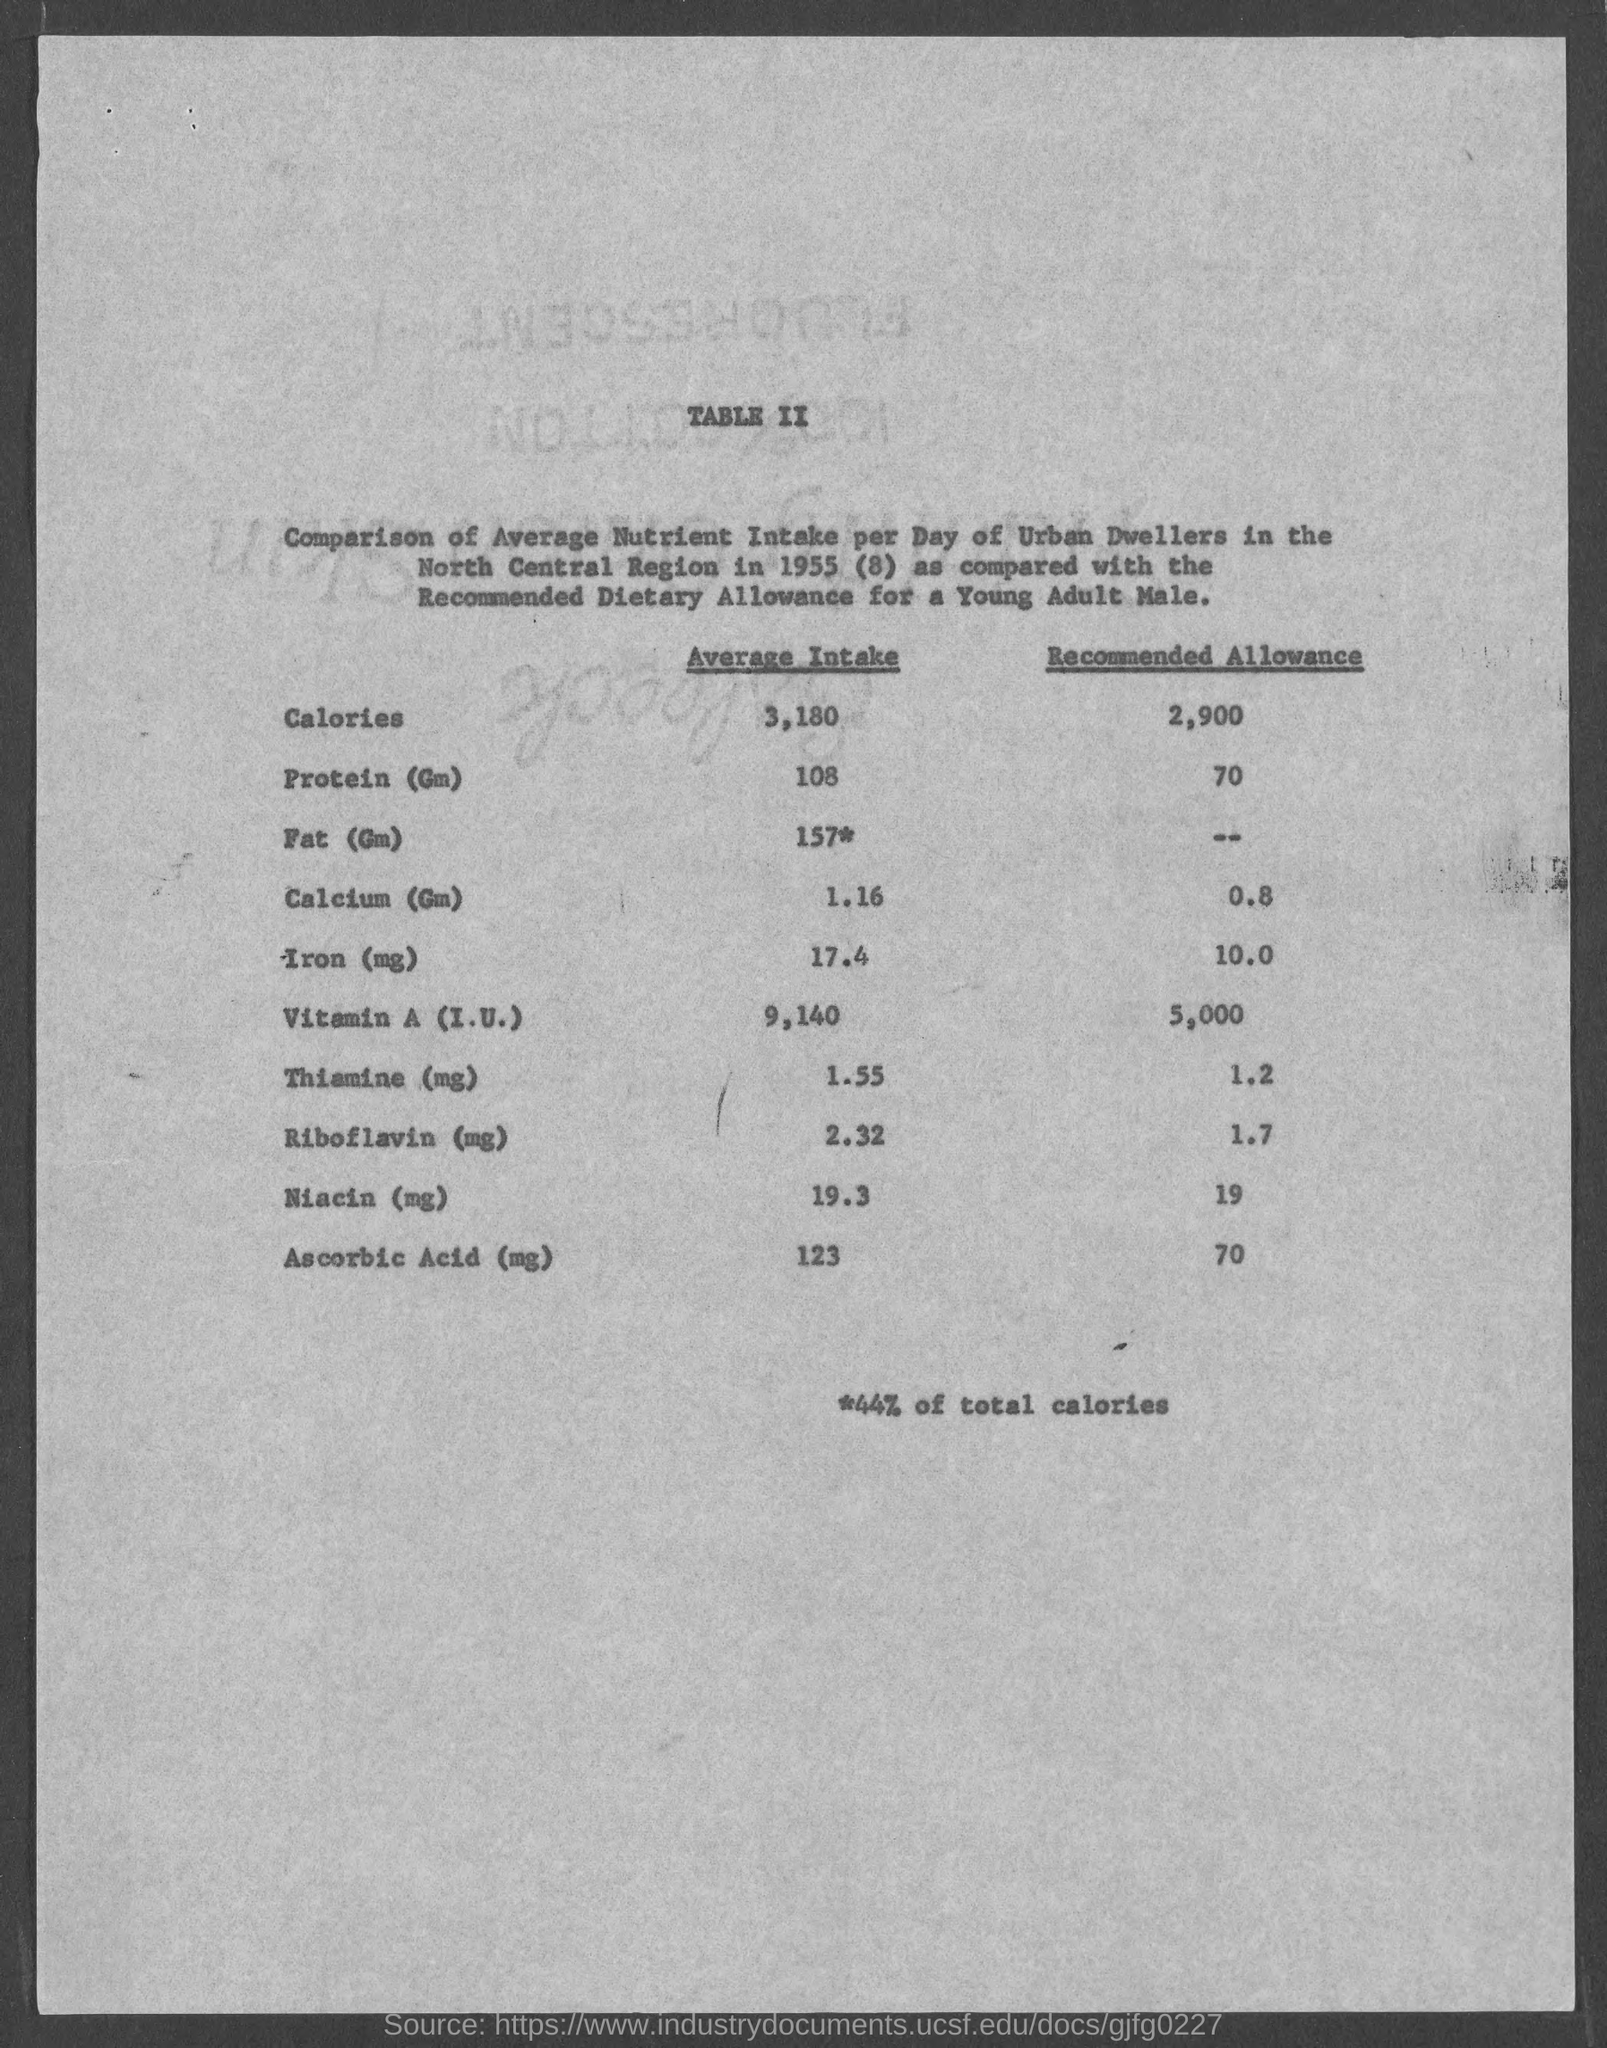Indicate a few pertinent items in this graphic. The average intake of fat (in grams) is 157. The average intake of Ascorbic Acid is approximately 123 milligrams per day. The average intake of Calcium is 1.16 grams per day. The average daily intake of iron is 17.4 milligrams. The average intake of calories is approximately 3,180 calories per day. 